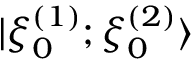Convert formula to latex. <formula><loc_0><loc_0><loc_500><loc_500>| \xi _ { 0 } ^ { ( 1 ) } ; \xi _ { 0 } ^ { ( 2 ) } \rangle</formula> 